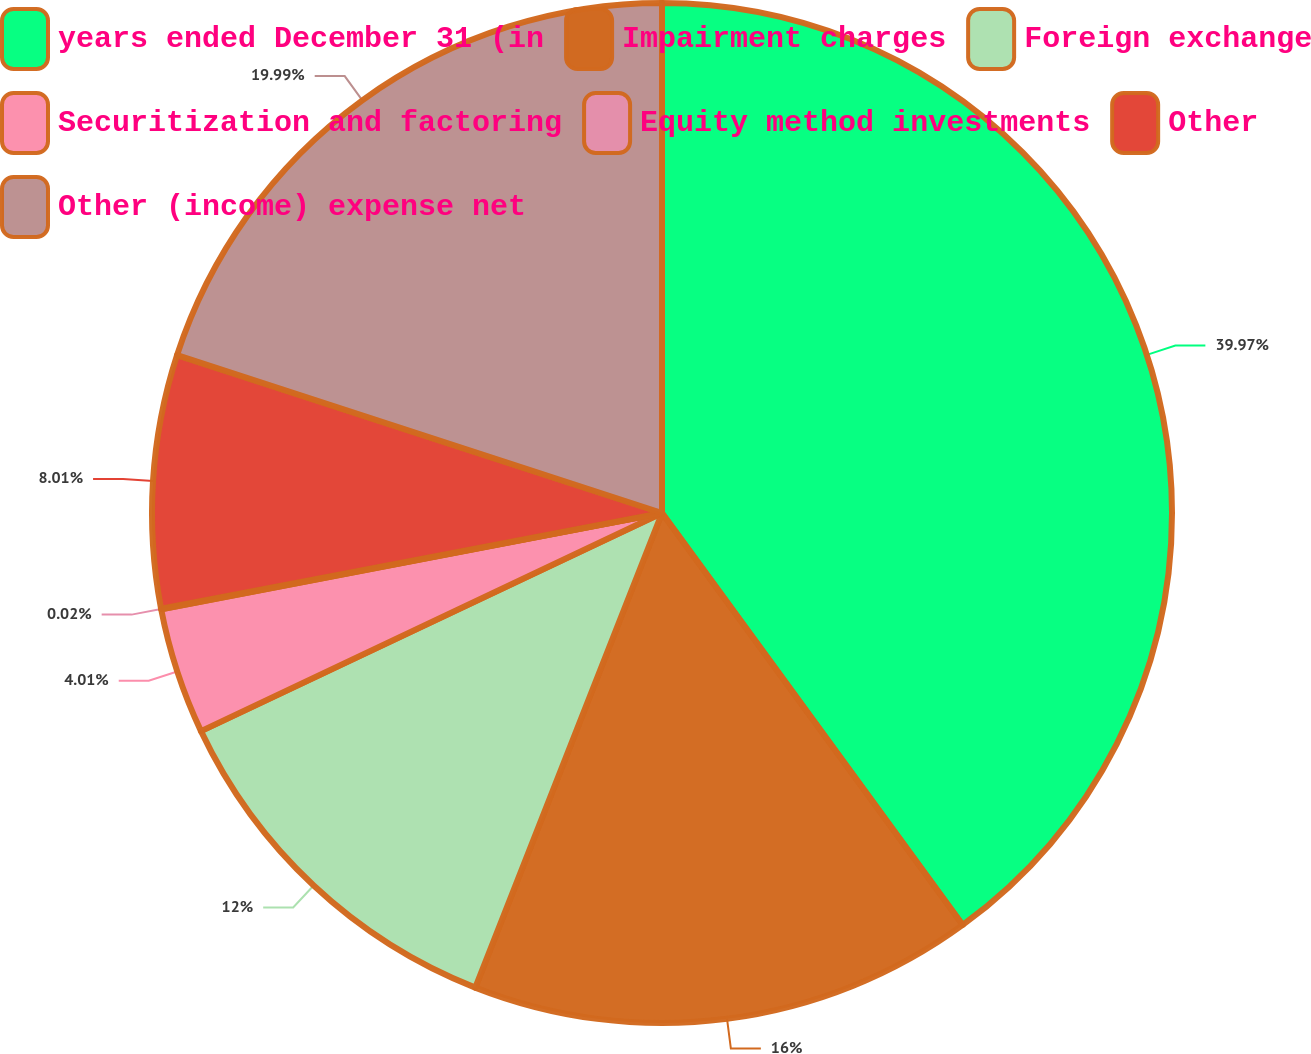Convert chart. <chart><loc_0><loc_0><loc_500><loc_500><pie_chart><fcel>years ended December 31 (in<fcel>Impairment charges<fcel>Foreign exchange<fcel>Securitization and factoring<fcel>Equity method investments<fcel>Other<fcel>Other (income) expense net<nl><fcel>39.96%<fcel>16.0%<fcel>12.0%<fcel>4.01%<fcel>0.02%<fcel>8.01%<fcel>19.99%<nl></chart> 